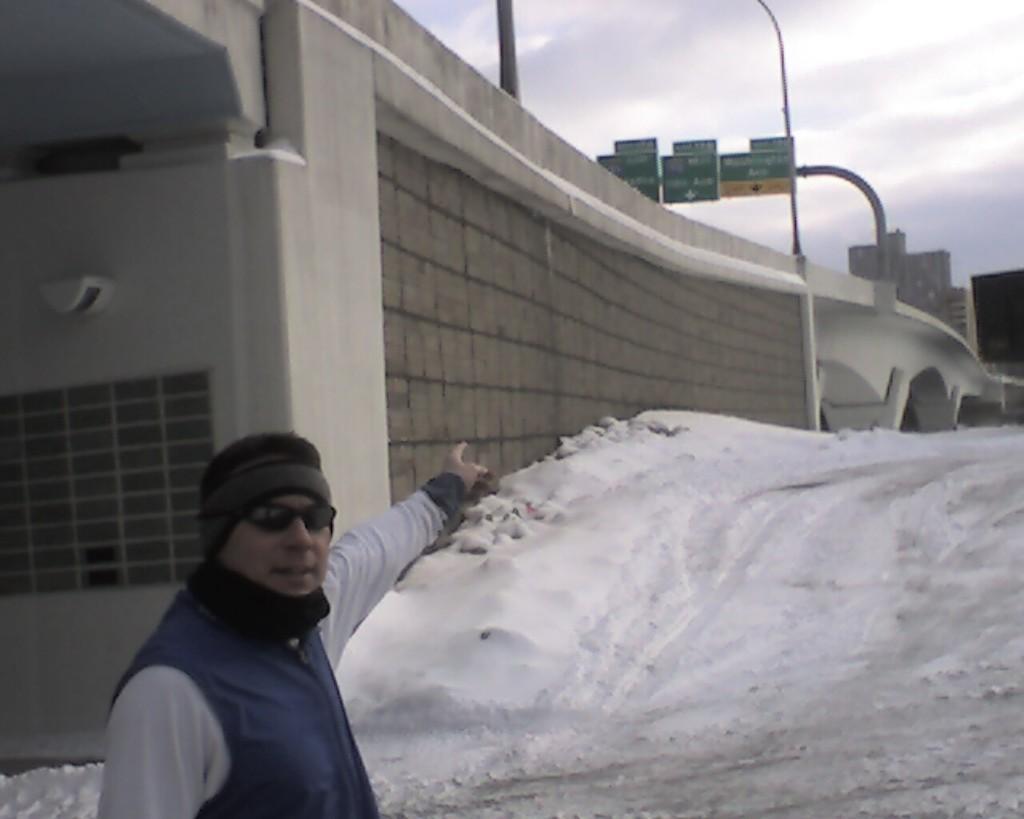Can you describe this image briefly? In this image I can see a person wearing white colored dress and blue jacket is standing. In the background I can see the bridge, few boards, some snow, few buildings and the sky. 